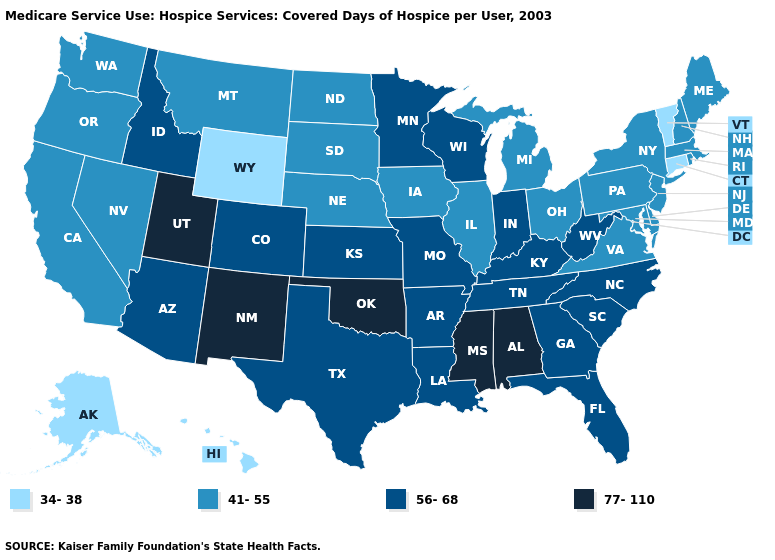Does Maine have a higher value than South Carolina?
Answer briefly. No. What is the value of Nebraska?
Answer briefly. 41-55. Does Vermont have the lowest value in the Northeast?
Give a very brief answer. Yes. Among the states that border Connecticut , which have the lowest value?
Quick response, please. Massachusetts, New York, Rhode Island. Among the states that border Michigan , which have the highest value?
Write a very short answer. Indiana, Wisconsin. What is the value of Minnesota?
Quick response, please. 56-68. Does the first symbol in the legend represent the smallest category?
Quick response, please. Yes. Name the states that have a value in the range 77-110?
Be succinct. Alabama, Mississippi, New Mexico, Oklahoma, Utah. Does the map have missing data?
Quick response, please. No. What is the highest value in the South ?
Short answer required. 77-110. Does New Mexico have the lowest value in the USA?
Quick response, please. No. Name the states that have a value in the range 41-55?
Write a very short answer. California, Delaware, Illinois, Iowa, Maine, Maryland, Massachusetts, Michigan, Montana, Nebraska, Nevada, New Hampshire, New Jersey, New York, North Dakota, Ohio, Oregon, Pennsylvania, Rhode Island, South Dakota, Virginia, Washington. What is the value of Utah?
Short answer required. 77-110. What is the highest value in the Northeast ?
Short answer required. 41-55. What is the highest value in states that border Rhode Island?
Concise answer only. 41-55. 